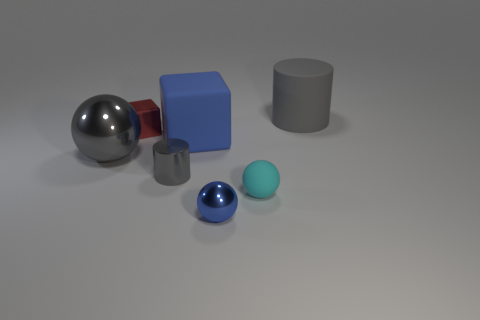Is there a tiny blue thing that has the same material as the blue block?
Your answer should be very brief. No. There is a small rubber ball to the right of the gray cylinder to the left of the big matte cube; is there a cylinder that is on the right side of it?
Offer a very short reply. Yes. How many other things are there of the same shape as the blue rubber thing?
Provide a short and direct response. 1. What is the color of the tiny metal thing that is behind the cylinder that is in front of the big gray object on the left side of the tiny blue shiny thing?
Ensure brevity in your answer.  Red. What number of big gray shiny things are there?
Offer a terse response. 1. How many small objects are cylinders or red blocks?
Provide a short and direct response. 2. There is a blue object that is the same size as the cyan sphere; what is its shape?
Offer a very short reply. Sphere. There is a gray thing that is to the right of the big matte object that is left of the gray rubber object; what is it made of?
Give a very brief answer. Rubber. Does the gray matte thing have the same size as the blue rubber object?
Your answer should be very brief. Yes. How many objects are small shiny balls to the left of the rubber ball or big red matte cubes?
Give a very brief answer. 1. 